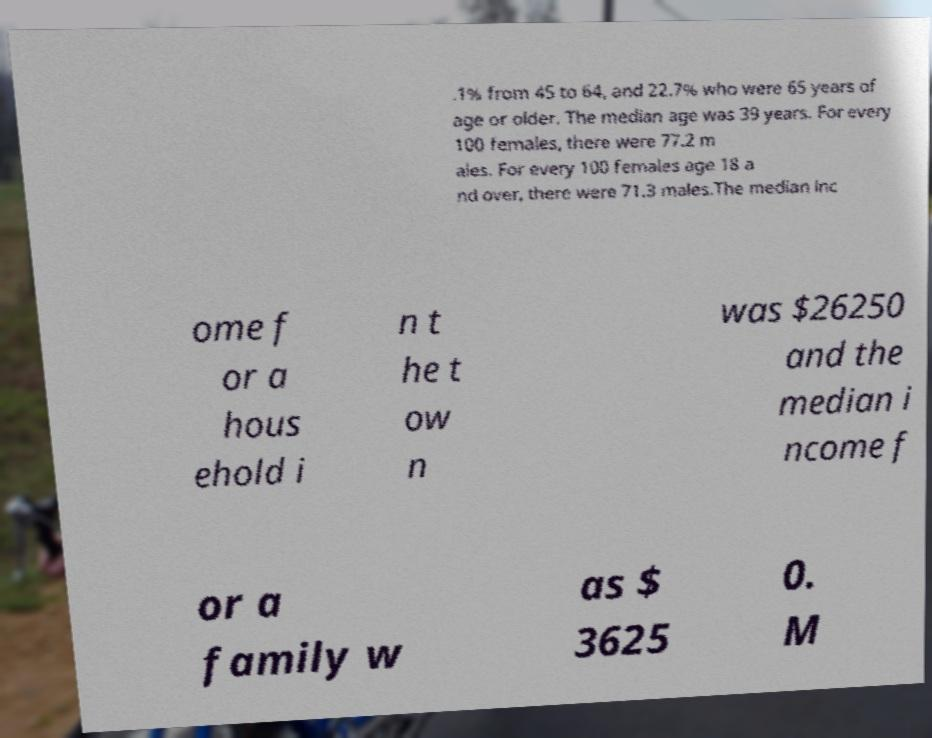Can you read and provide the text displayed in the image?This photo seems to have some interesting text. Can you extract and type it out for me? .1% from 45 to 64, and 22.7% who were 65 years of age or older. The median age was 39 years. For every 100 females, there were 77.2 m ales. For every 100 females age 18 a nd over, there were 71.3 males.The median inc ome f or a hous ehold i n t he t ow n was $26250 and the median i ncome f or a family w as $ 3625 0. M 